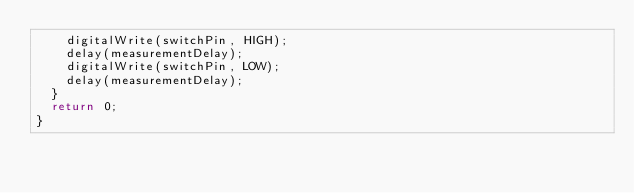Convert code to text. <code><loc_0><loc_0><loc_500><loc_500><_C++_>    digitalWrite(switchPin, HIGH); 
    delay(measurementDelay);
    digitalWrite(switchPin, LOW); 
    delay(measurementDelay);
  }
  return 0;
}

</code> 